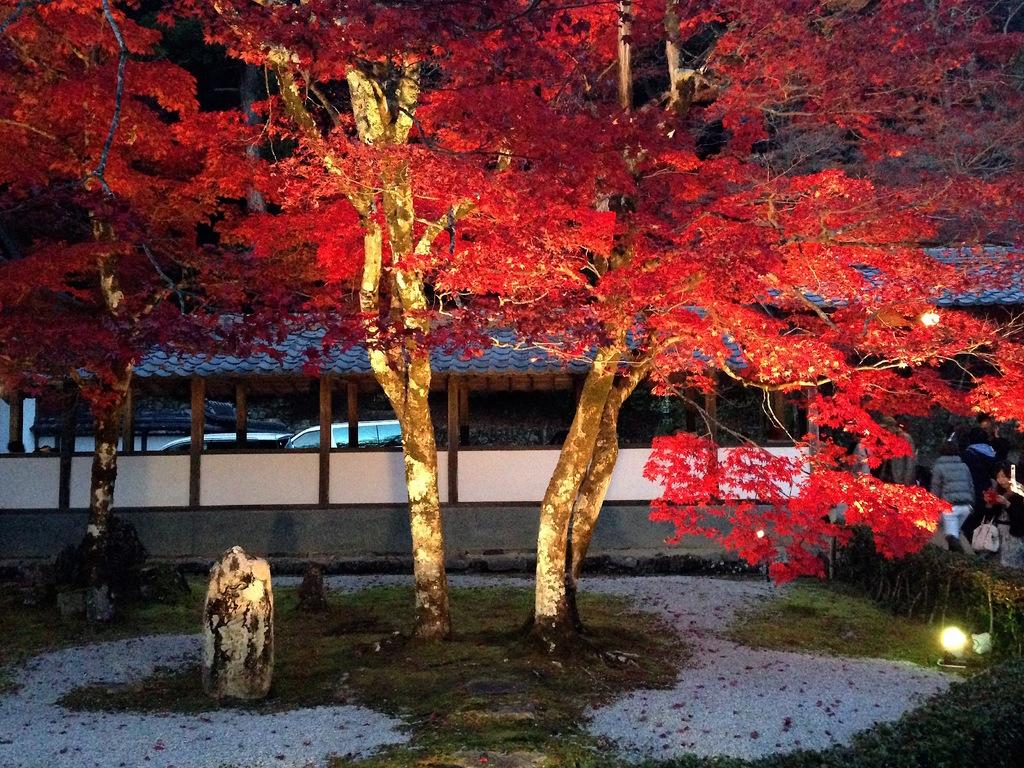What type of natural environment is visible in the image? There is grass and trees visible in the image. What can be seen in the background of the image? There are lights, people, a shed, a wall, and vehicles visible in the background of the image. What type of salt can be seen being sprinkled on the trail in the image? There is no salt or trail present in the image. What type of truck can be seen parked near the shed in the image? There is no truck present in the image. 